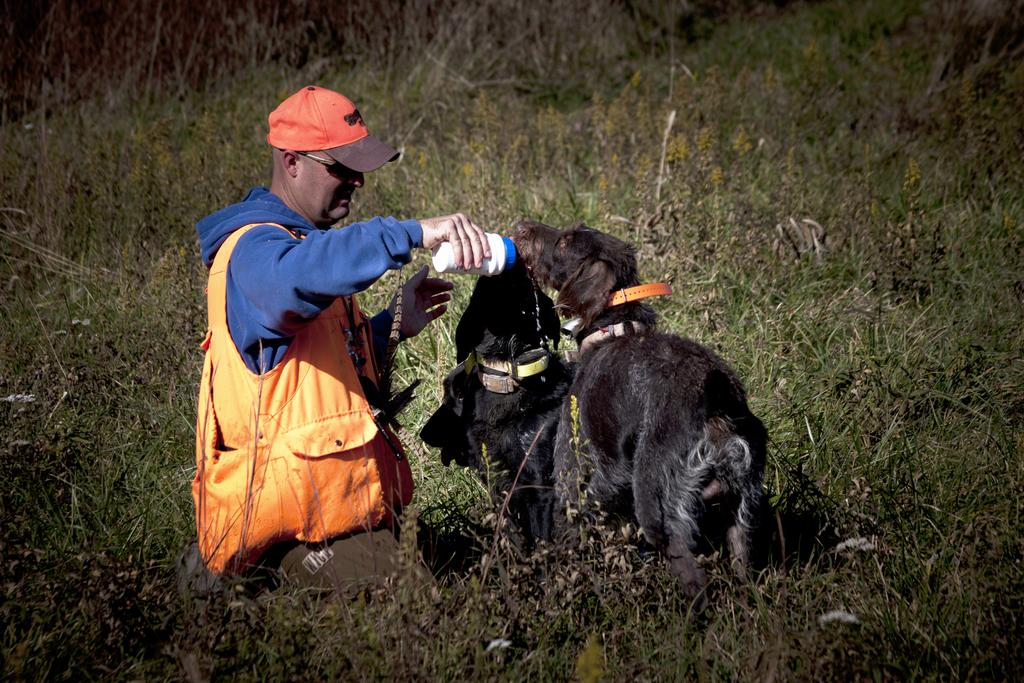What type of animals are in the image? There are dogs in the image. Who else is present in the image? There is a man in the image. What is the man wearing on his head? The man is wearing a cap. What is the man holding in the image? The man is holding a bottle. What type of vegetation can be seen in the image? There are plants in the image. What type of car can be seen in the image? There is no car present in the image. What type of grass is being used as a basket in the image? There is no grass or basket present in the image. 